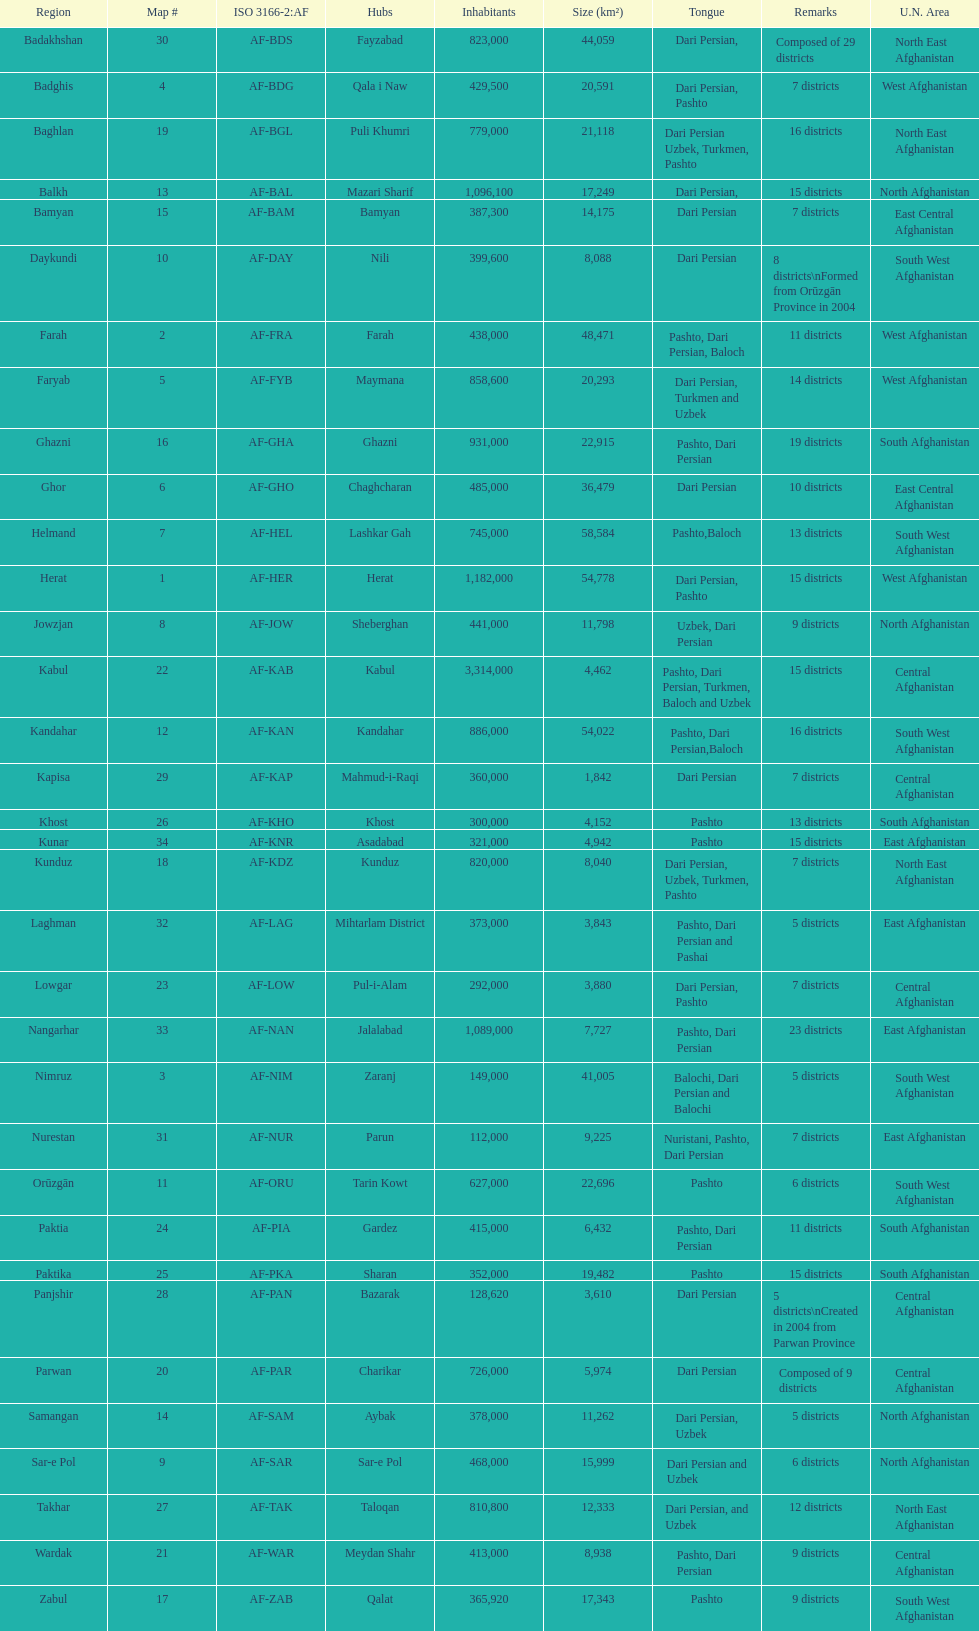How many districts exist within the province of kunduz? 7. 